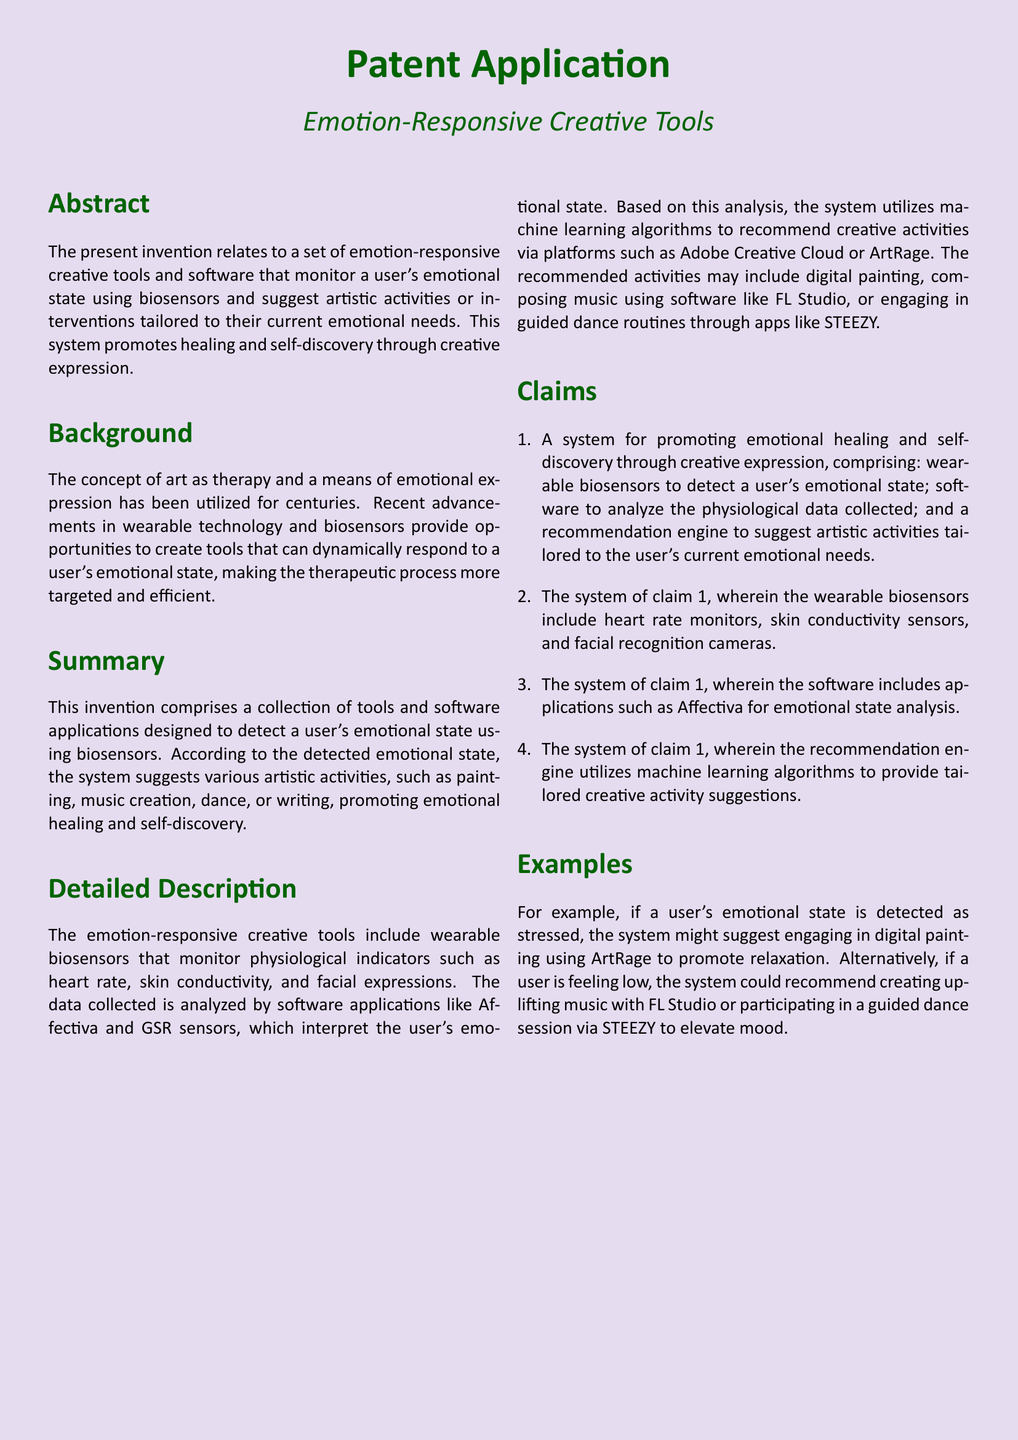What is the title of the invention? The title of the invention is provided at the top of the document.
Answer: Emotion-Responsive Creative Tools What is the primary purpose of the invention? The primary purpose is mentioned in the abstract section.
Answer: Promote healing and self-discovery through creative expression Which technologies are cited for emotional state analysis? The software applications mentioned in the detailed description include specific names.
Answer: Affectiva What physiological indicators do the biosensors monitor? The document lists specific physiological indicators in the claims section.
Answer: Heart rate, skin conductivity, and facial expressions What type of algorithms does the recommendation engine utilize? The detailed description specifies the type of algorithms used in the recommendation system.
Answer: Machine learning algorithms What is an example of an artistic activity suggested for stress relief? An example is provided in the examples section for stress-related emotions.
Answer: Digital painting using ArtRage In which section is the background discussed? The background information is found in a specific section of the document.
Answer: Background How many claims are stated in the document? The number of claims is indicated in the claims section.
Answer: Four claims 